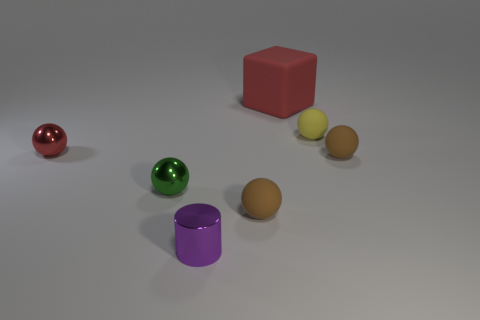Subtract all green balls. How many balls are left? 4 Subtract all small red balls. How many balls are left? 4 Subtract all blue balls. Subtract all brown cubes. How many balls are left? 5 Add 2 big cyan cubes. How many objects exist? 9 Subtract all cubes. How many objects are left? 6 Subtract all blocks. Subtract all tiny brown rubber things. How many objects are left? 4 Add 3 green balls. How many green balls are left? 4 Add 5 large red blocks. How many large red blocks exist? 6 Subtract 0 gray balls. How many objects are left? 7 